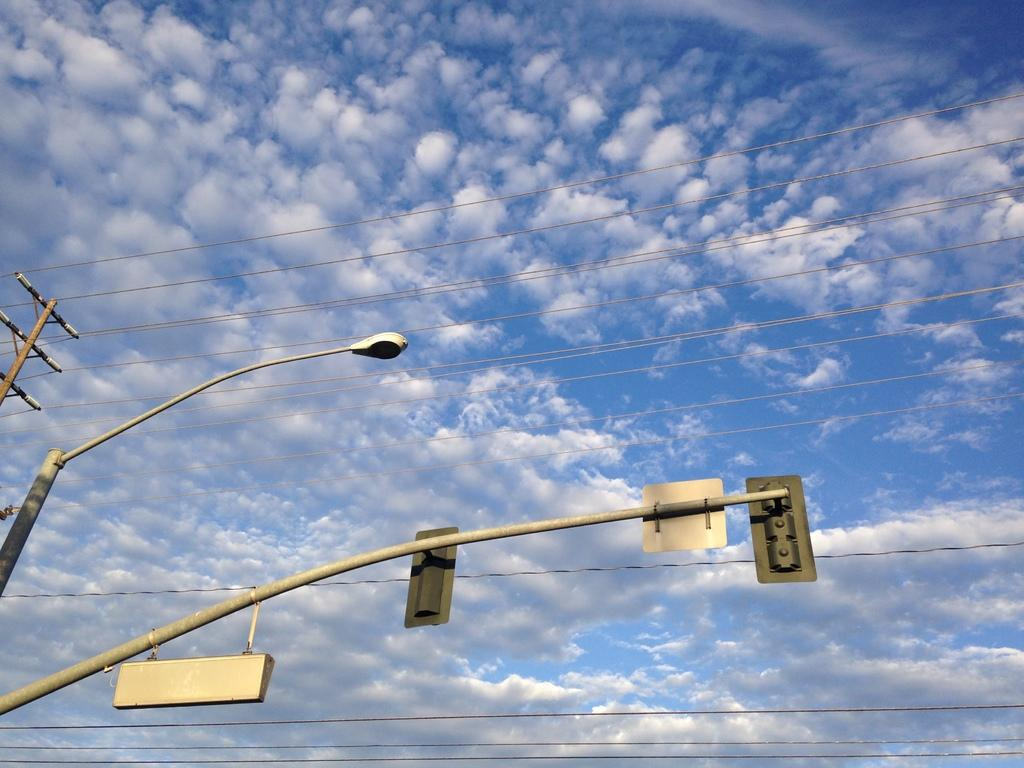What is connected with wires in the image? There is an electric pole connected with wires in the image. What other type of pole can be seen in the image? There is a light pole in the image. What is attached to the pole with boards? There are boards on a pole in the image. How would you describe the sky in the image? The sky is cloudy in the image. How does the electric pole aid in the digestion process in the image? The electric pole does not aid in the digestion process in the image; it is a structure for transmitting electricity. 